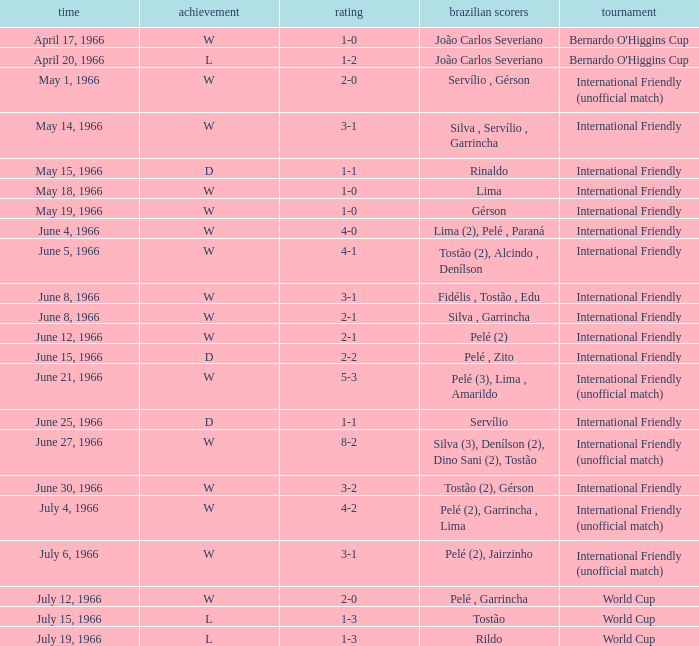What competition has a result of W on June 30, 1966? International Friendly. 